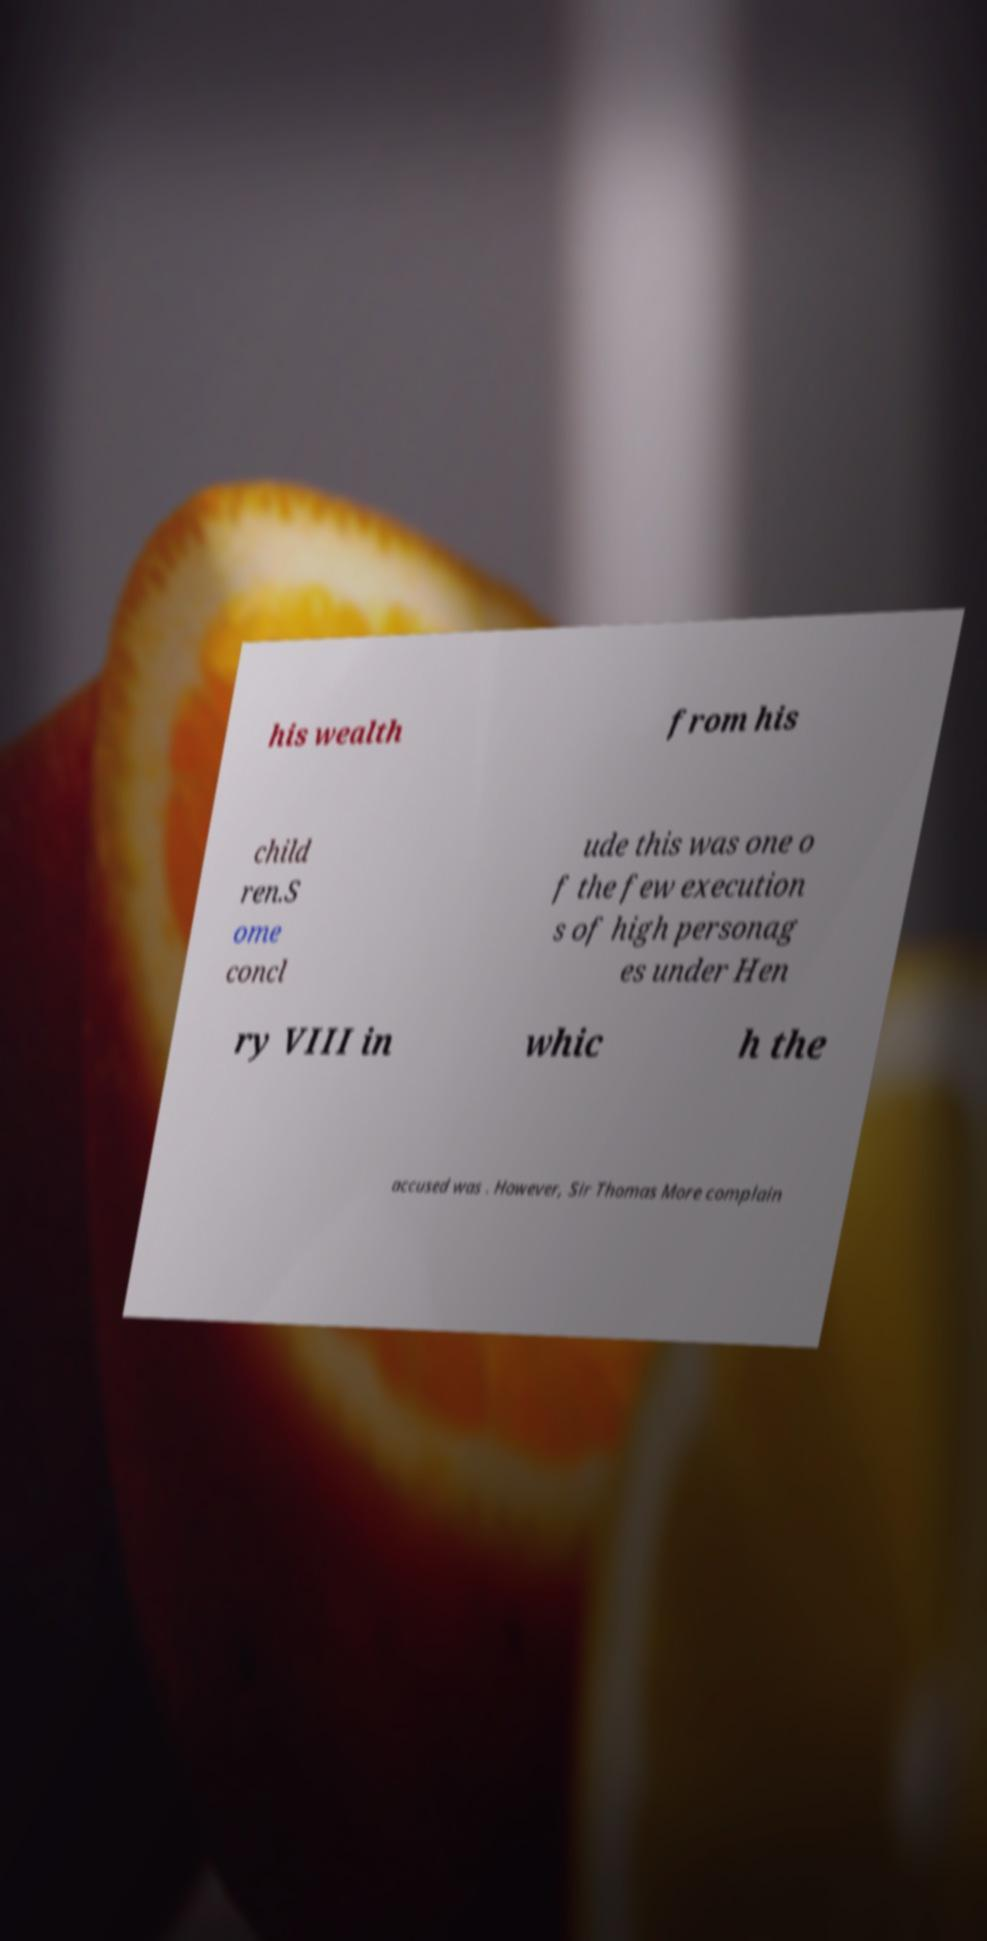Could you extract and type out the text from this image? his wealth from his child ren.S ome concl ude this was one o f the few execution s of high personag es under Hen ry VIII in whic h the accused was . However, Sir Thomas More complain 